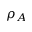Convert formula to latex. <formula><loc_0><loc_0><loc_500><loc_500>\rho _ { A }</formula> 